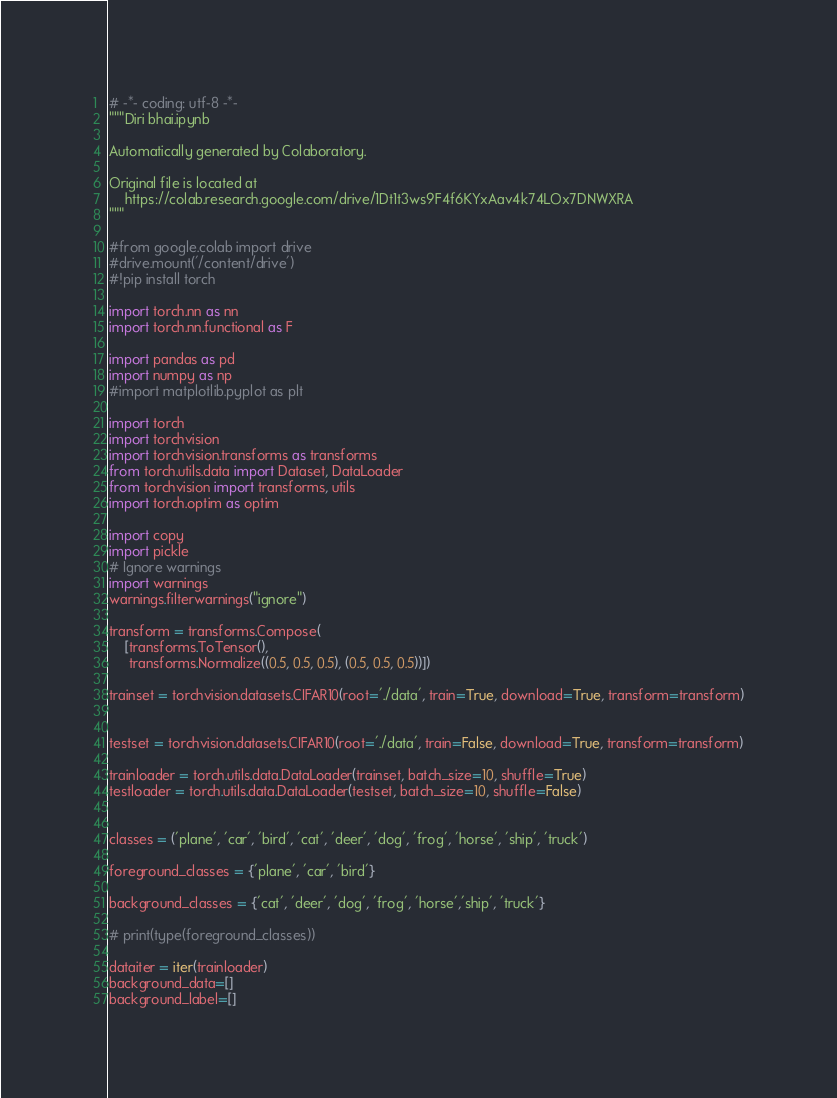Convert code to text. <code><loc_0><loc_0><loc_500><loc_500><_Python_># -*- coding: utf-8 -*-
"""Diri bhai.ipynb

Automatically generated by Colaboratory.

Original file is located at
    https://colab.research.google.com/drive/1Dt1t3ws9F4f6KYxAav4k74LOx7DNWXRA
"""

#from google.colab import drive
#drive.mount('/content/drive')
#!pip install torch

import torch.nn as nn
import torch.nn.functional as F

import pandas as pd
import numpy as np
#import matplotlib.pyplot as plt

import torch
import torchvision
import torchvision.transforms as transforms
from torch.utils.data import Dataset, DataLoader
from torchvision import transforms, utils
import torch.optim as optim

import copy
import pickle
# Ignore warnings
import warnings
warnings.filterwarnings("ignore")

transform = transforms.Compose(
    [transforms.ToTensor(),
     transforms.Normalize((0.5, 0.5, 0.5), (0.5, 0.5, 0.5))])

trainset = torchvision.datasets.CIFAR10(root='./data', train=True, download=True, transform=transform)


testset = torchvision.datasets.CIFAR10(root='./data', train=False, download=True, transform=transform)

trainloader = torch.utils.data.DataLoader(trainset, batch_size=10, shuffle=True)
testloader = torch.utils.data.DataLoader(testset, batch_size=10, shuffle=False)


classes = ('plane', 'car', 'bird', 'cat', 'deer', 'dog', 'frog', 'horse', 'ship', 'truck')

foreground_classes = {'plane', 'car', 'bird'}

background_classes = {'cat', 'deer', 'dog', 'frog', 'horse','ship', 'truck'}

# print(type(foreground_classes))

dataiter = iter(trainloader)
background_data=[]
background_label=[]</code> 